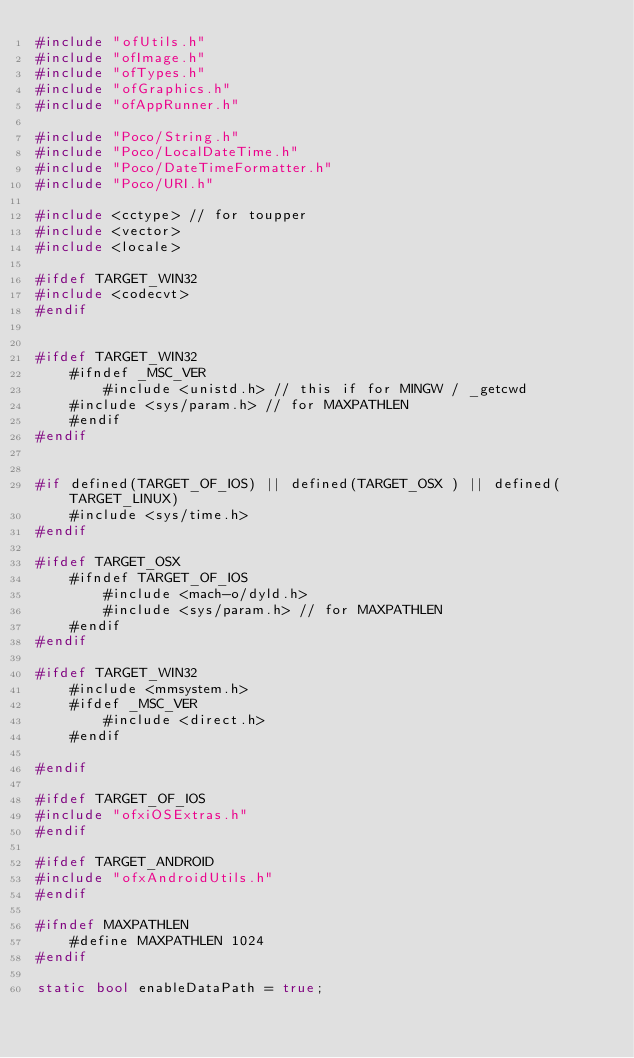Convert code to text. <code><loc_0><loc_0><loc_500><loc_500><_C++_>#include "ofUtils.h"
#include "ofImage.h"
#include "ofTypes.h"
#include "ofGraphics.h"
#include "ofAppRunner.h"

#include "Poco/String.h"
#include "Poco/LocalDateTime.h"
#include "Poco/DateTimeFormatter.h"
#include "Poco/URI.h"

#include <cctype> // for toupper
#include <vector>
#include <locale>

#ifdef TARGET_WIN32
#include <codecvt>
#endif


#ifdef TARGET_WIN32
    #ifndef _MSC_VER
        #include <unistd.h> // this if for MINGW / _getcwd
	#include <sys/param.h> // for MAXPATHLEN
    #endif
#endif


#if defined(TARGET_OF_IOS) || defined(TARGET_OSX ) || defined(TARGET_LINUX)
	#include <sys/time.h>
#endif

#ifdef TARGET_OSX
	#ifndef TARGET_OF_IOS
		#include <mach-o/dyld.h>
		#include <sys/param.h> // for MAXPATHLEN
	#endif
#endif

#ifdef TARGET_WIN32
    #include <mmsystem.h>
	#ifdef _MSC_VER
		#include <direct.h>
	#endif

#endif

#ifdef TARGET_OF_IOS
#include "ofxiOSExtras.h"
#endif

#ifdef TARGET_ANDROID
#include "ofxAndroidUtils.h"
#endif

#ifndef MAXPATHLEN
	#define MAXPATHLEN 1024
#endif

static bool enableDataPath = true;</code> 